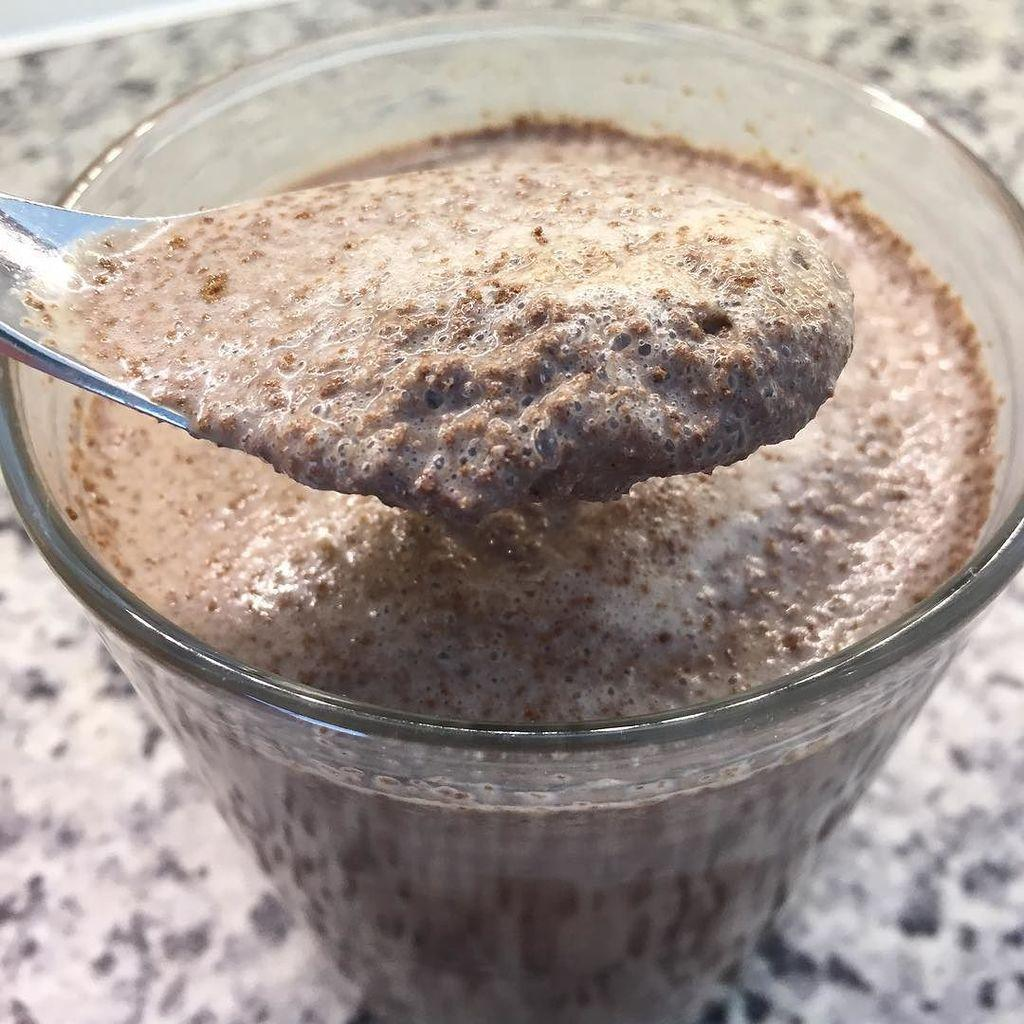What is inside the glass that is visible in the image? There is a food item in a glass. What utensil is placed with the glass? There is a spoon on the glass. On what surface is the glass placed? The glass is on a marble platform. How many people are standing on the shelf in the image? There is no shelf present in the image, and therefore no people standing on it. 